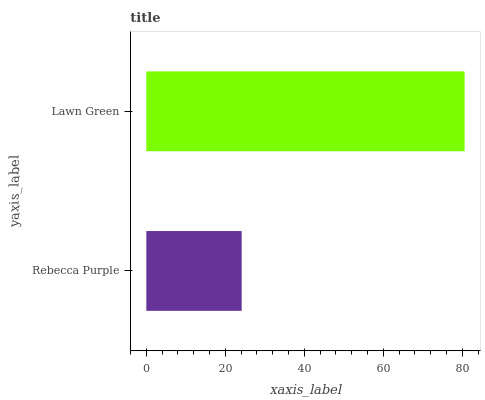Is Rebecca Purple the minimum?
Answer yes or no. Yes. Is Lawn Green the maximum?
Answer yes or no. Yes. Is Lawn Green the minimum?
Answer yes or no. No. Is Lawn Green greater than Rebecca Purple?
Answer yes or no. Yes. Is Rebecca Purple less than Lawn Green?
Answer yes or no. Yes. Is Rebecca Purple greater than Lawn Green?
Answer yes or no. No. Is Lawn Green less than Rebecca Purple?
Answer yes or no. No. Is Lawn Green the high median?
Answer yes or no. Yes. Is Rebecca Purple the low median?
Answer yes or no. Yes. Is Rebecca Purple the high median?
Answer yes or no. No. Is Lawn Green the low median?
Answer yes or no. No. 